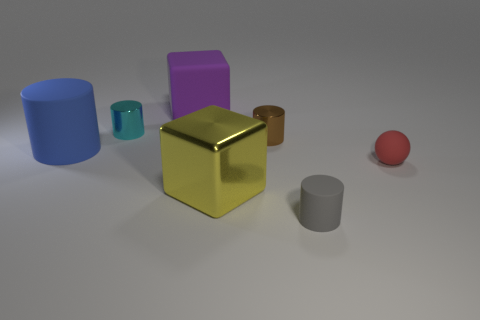Add 1 matte blocks. How many objects exist? 8 Subtract all balls. How many objects are left? 6 Subtract all big yellow spheres. Subtract all cylinders. How many objects are left? 3 Add 6 big rubber things. How many big rubber things are left? 8 Add 6 yellow spheres. How many yellow spheres exist? 6 Subtract 1 gray cylinders. How many objects are left? 6 